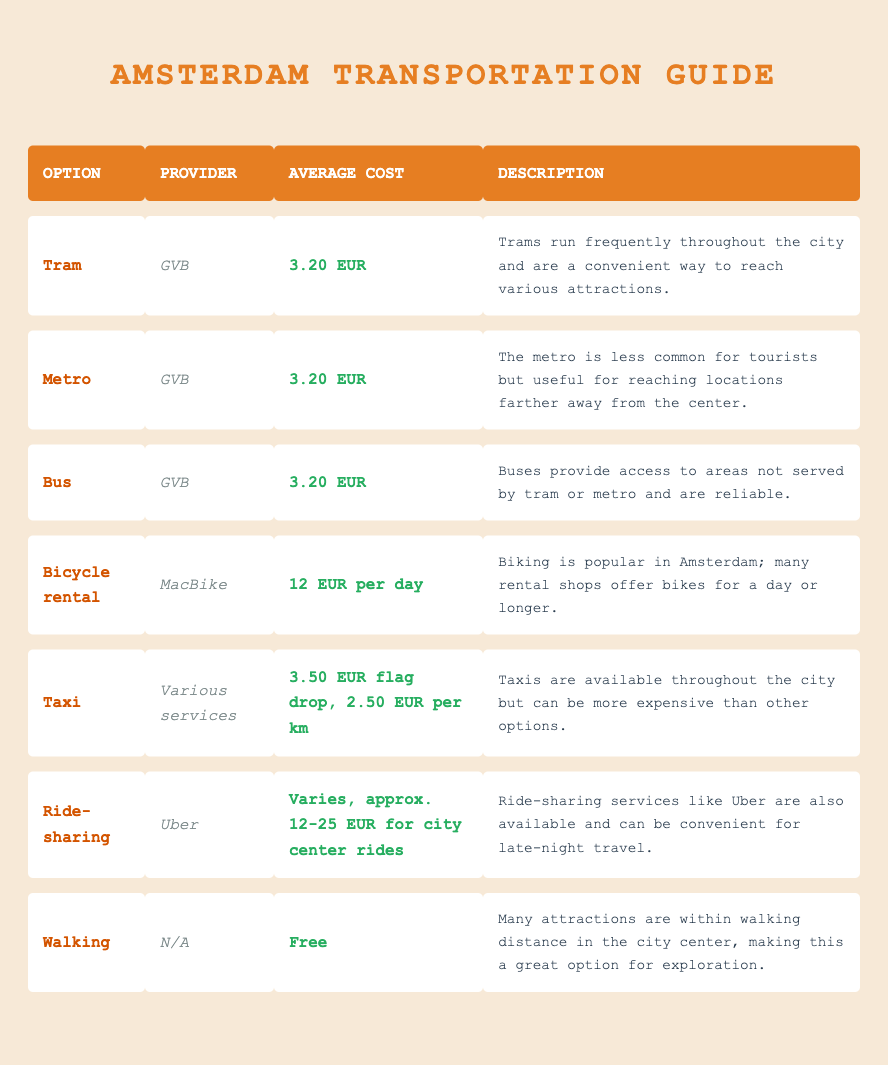What is the average cost of taking a tram in Amsterdam? The average cost for taking a tram in Amsterdam is listed as 3.20 EUR. This value is found directly in the row corresponding to the tram option.
Answer: 3.20 EUR Are taxis more expensive than buses? The average cost for a taxi is 3.50 EUR for the flag drop plus 2.50 EUR per km, while the average bus fare is 3.20 EUR. Since 3.50 EUR (flag drop) is already higher than the bus fare, taxis are indeed more expensive than buses.
Answer: Yes What is the cost difference between bicycle rental and tram fares? The average cost for bicycle rental is 12 EUR per day, while the tram fare is 3.20 EUR. The cost difference is calculated as 12 - 3.20 = 8.80 EUR, indicating that bicycle rental is more expensive than tram fares by 8.80 EUR.
Answer: 8.80 EUR Is walking a viable option for getting around the city center? The description under the walking option indicates that many attractions are within walking distance in the city center, making walking a viable transportation choice.
Answer: Yes Which transportation option has the highest average cost? Comparing the average costs, the bicycle rental at 12 EUR per day is the highest, since tram, metro, and bus each cost 3.20 EUR and the taxi costs depending on distance. Thus, bicycle rental is the option with the highest average cost.
Answer: Bicycle rental 